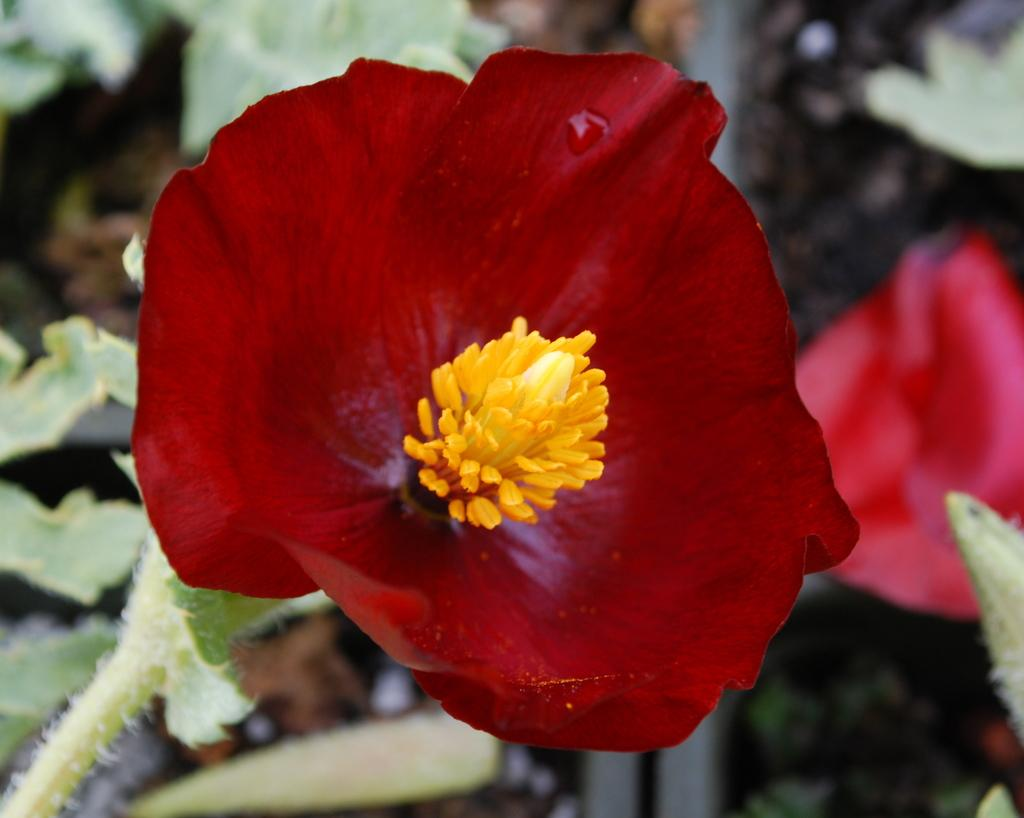What type of flower is present in the image? There is a red flower with a plant in the image. Can you describe any specific details about the flower? There is a water drop visible on the flower in the image. What else can be seen on the right side of the image? There are objects visible on the right side of the image. What type of vegetation is present in the image? There are leaves visible in the image. What is the background of the flower? There is ground visible in the image. What type of feather can be seen on the body of the print in the image? There is no feather or print present in the image; it features a red flower with a plant, leaves, and ground. 